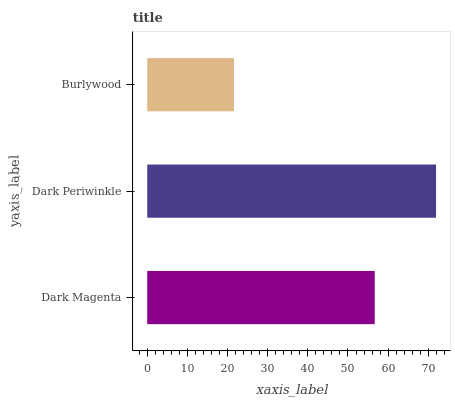Is Burlywood the minimum?
Answer yes or no. Yes. Is Dark Periwinkle the maximum?
Answer yes or no. Yes. Is Dark Periwinkle the minimum?
Answer yes or no. No. Is Burlywood the maximum?
Answer yes or no. No. Is Dark Periwinkle greater than Burlywood?
Answer yes or no. Yes. Is Burlywood less than Dark Periwinkle?
Answer yes or no. Yes. Is Burlywood greater than Dark Periwinkle?
Answer yes or no. No. Is Dark Periwinkle less than Burlywood?
Answer yes or no. No. Is Dark Magenta the high median?
Answer yes or no. Yes. Is Dark Magenta the low median?
Answer yes or no. Yes. Is Dark Periwinkle the high median?
Answer yes or no. No. Is Burlywood the low median?
Answer yes or no. No. 